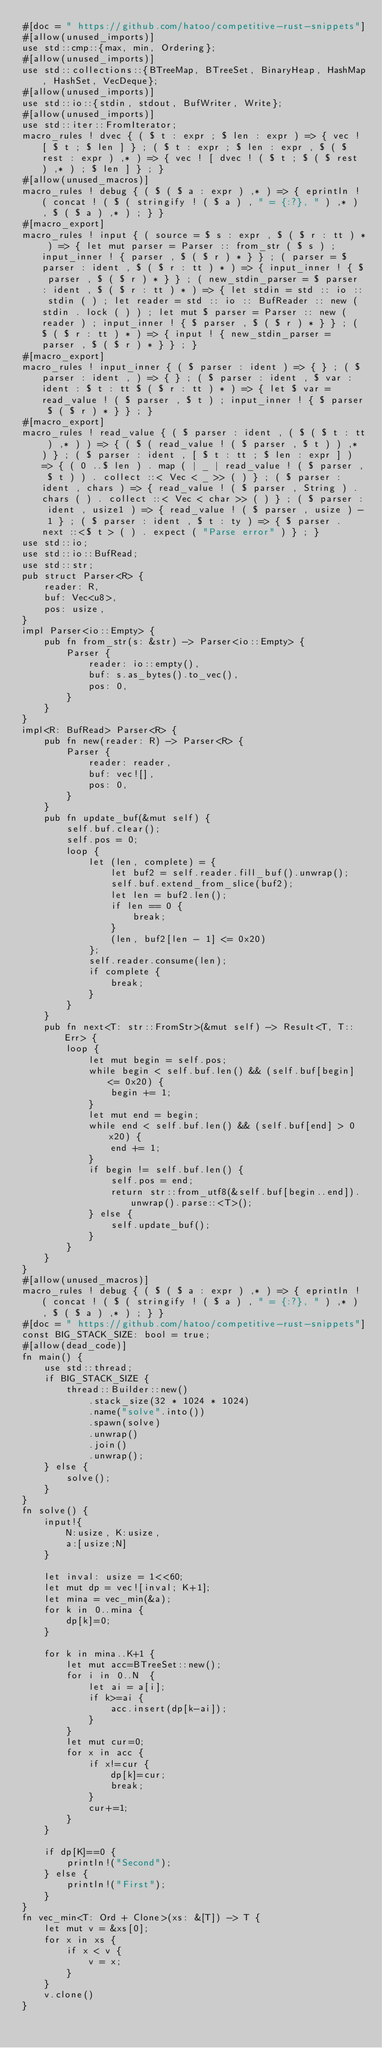<code> <loc_0><loc_0><loc_500><loc_500><_Rust_>#[doc = " https://github.com/hatoo/competitive-rust-snippets"]
#[allow(unused_imports)]
use std::cmp::{max, min, Ordering};
#[allow(unused_imports)]
use std::collections::{BTreeMap, BTreeSet, BinaryHeap, HashMap, HashSet, VecDeque};
#[allow(unused_imports)]
use std::io::{stdin, stdout, BufWriter, Write};
#[allow(unused_imports)]
use std::iter::FromIterator;
macro_rules ! dvec { ( $ t : expr ; $ len : expr ) => { vec ! [ $ t ; $ len ] } ; ( $ t : expr ; $ len : expr , $ ( $ rest : expr ) ,* ) => { vec ! [ dvec ! ( $ t ; $ ( $ rest ) ,* ) ; $ len ] } ; }
#[allow(unused_macros)]
macro_rules ! debug { ( $ ( $ a : expr ) ,* ) => { eprintln ! ( concat ! ( $ ( stringify ! ( $ a ) , " = {:?}, " ) ,* ) , $ ( $ a ) ,* ) ; } }
#[macro_export]
macro_rules ! input { ( source = $ s : expr , $ ( $ r : tt ) * ) => { let mut parser = Parser :: from_str ( $ s ) ; input_inner ! { parser , $ ( $ r ) * } } ; ( parser = $ parser : ident , $ ( $ r : tt ) * ) => { input_inner ! { $ parser , $ ( $ r ) * } } ; ( new_stdin_parser = $ parser : ident , $ ( $ r : tt ) * ) => { let stdin = std :: io :: stdin ( ) ; let reader = std :: io :: BufReader :: new ( stdin . lock ( ) ) ; let mut $ parser = Parser :: new ( reader ) ; input_inner ! { $ parser , $ ( $ r ) * } } ; ( $ ( $ r : tt ) * ) => { input ! { new_stdin_parser = parser , $ ( $ r ) * } } ; }
#[macro_export]
macro_rules ! input_inner { ( $ parser : ident ) => { } ; ( $ parser : ident , ) => { } ; ( $ parser : ident , $ var : ident : $ t : tt $ ( $ r : tt ) * ) => { let $ var = read_value ! ( $ parser , $ t ) ; input_inner ! { $ parser $ ( $ r ) * } } ; }
#[macro_export]
macro_rules ! read_value { ( $ parser : ident , ( $ ( $ t : tt ) ,* ) ) => { ( $ ( read_value ! ( $ parser , $ t ) ) ,* ) } ; ( $ parser : ident , [ $ t : tt ; $ len : expr ] ) => { ( 0 ..$ len ) . map ( | _ | read_value ! ( $ parser , $ t ) ) . collect ::< Vec < _ >> ( ) } ; ( $ parser : ident , chars ) => { read_value ! ( $ parser , String ) . chars ( ) . collect ::< Vec < char >> ( ) } ; ( $ parser : ident , usize1 ) => { read_value ! ( $ parser , usize ) - 1 } ; ( $ parser : ident , $ t : ty ) => { $ parser . next ::<$ t > ( ) . expect ( "Parse error" ) } ; }
use std::io;
use std::io::BufRead;
use std::str;
pub struct Parser<R> {
    reader: R,
    buf: Vec<u8>,
    pos: usize,
}
impl Parser<io::Empty> {
    pub fn from_str(s: &str) -> Parser<io::Empty> {
        Parser {
            reader: io::empty(),
            buf: s.as_bytes().to_vec(),
            pos: 0,
        }
    }
}
impl<R: BufRead> Parser<R> {
    pub fn new(reader: R) -> Parser<R> {
        Parser {
            reader: reader,
            buf: vec![],
            pos: 0,
        }
    }
    pub fn update_buf(&mut self) {
        self.buf.clear();
        self.pos = 0;
        loop {
            let (len, complete) = {
                let buf2 = self.reader.fill_buf().unwrap();
                self.buf.extend_from_slice(buf2);
                let len = buf2.len();
                if len == 0 {
                    break;
                }
                (len, buf2[len - 1] <= 0x20)
            };
            self.reader.consume(len);
            if complete {
                break;
            }
        }
    }
    pub fn next<T: str::FromStr>(&mut self) -> Result<T, T::Err> {
        loop {
            let mut begin = self.pos;
            while begin < self.buf.len() && (self.buf[begin] <= 0x20) {
                begin += 1;
            }
            let mut end = begin;
            while end < self.buf.len() && (self.buf[end] > 0x20) {
                end += 1;
            }
            if begin != self.buf.len() {
                self.pos = end;
                return str::from_utf8(&self.buf[begin..end]).unwrap().parse::<T>();
            } else {
                self.update_buf();
            }
        }
    }
}
#[allow(unused_macros)]
macro_rules ! debug { ( $ ( $ a : expr ) ,* ) => { eprintln ! ( concat ! ( $ ( stringify ! ( $ a ) , " = {:?}, " ) ,* ) , $ ( $ a ) ,* ) ; } }
#[doc = " https://github.com/hatoo/competitive-rust-snippets"]
const BIG_STACK_SIZE: bool = true;
#[allow(dead_code)]
fn main() {
    use std::thread;
    if BIG_STACK_SIZE {
        thread::Builder::new()
            .stack_size(32 * 1024 * 1024)
            .name("solve".into())
            .spawn(solve)
            .unwrap()
            .join()
            .unwrap();
    } else {
        solve();
    }
}
fn solve() {
    input!{
        N:usize, K:usize,
        a:[usize;N]
    }

    let inval: usize = 1<<60;
    let mut dp = vec![inval; K+1];
    let mina = vec_min(&a);
    for k in 0..mina {
        dp[k]=0;
    }

    for k in mina..K+1 {
        let mut acc=BTreeSet::new();
        for i in 0..N  {
            let ai = a[i];
            if k>=ai {
                acc.insert(dp[k-ai]);
            }
        }
        let mut cur=0;
        for x in acc {
            if x!=cur {
                dp[k]=cur;
                break;
            }
            cur+=1;
        }
    }

    if dp[K]==0 {
        println!("Second");
    } else {
        println!("First");
    }
}
fn vec_min<T: Ord + Clone>(xs: &[T]) -> T {
    let mut v = &xs[0];
    for x in xs {
        if x < v {
            v = x;
        }
    }
    v.clone()
}</code> 